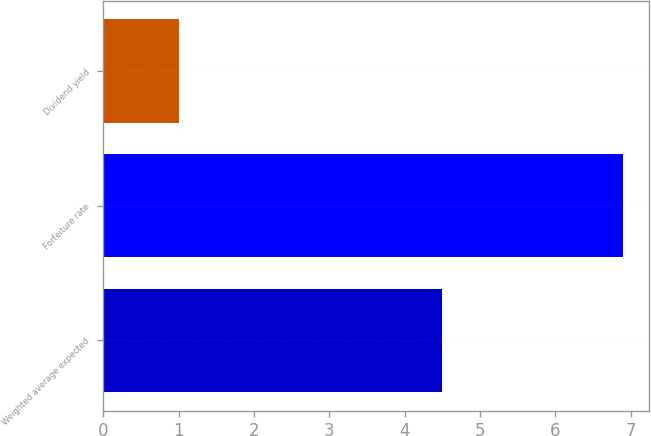Convert chart to OTSL. <chart><loc_0><loc_0><loc_500><loc_500><bar_chart><fcel>Weighted average expected<fcel>Forfeiture rate<fcel>Dividend yield<nl><fcel>4.5<fcel>6.9<fcel>1<nl></chart> 